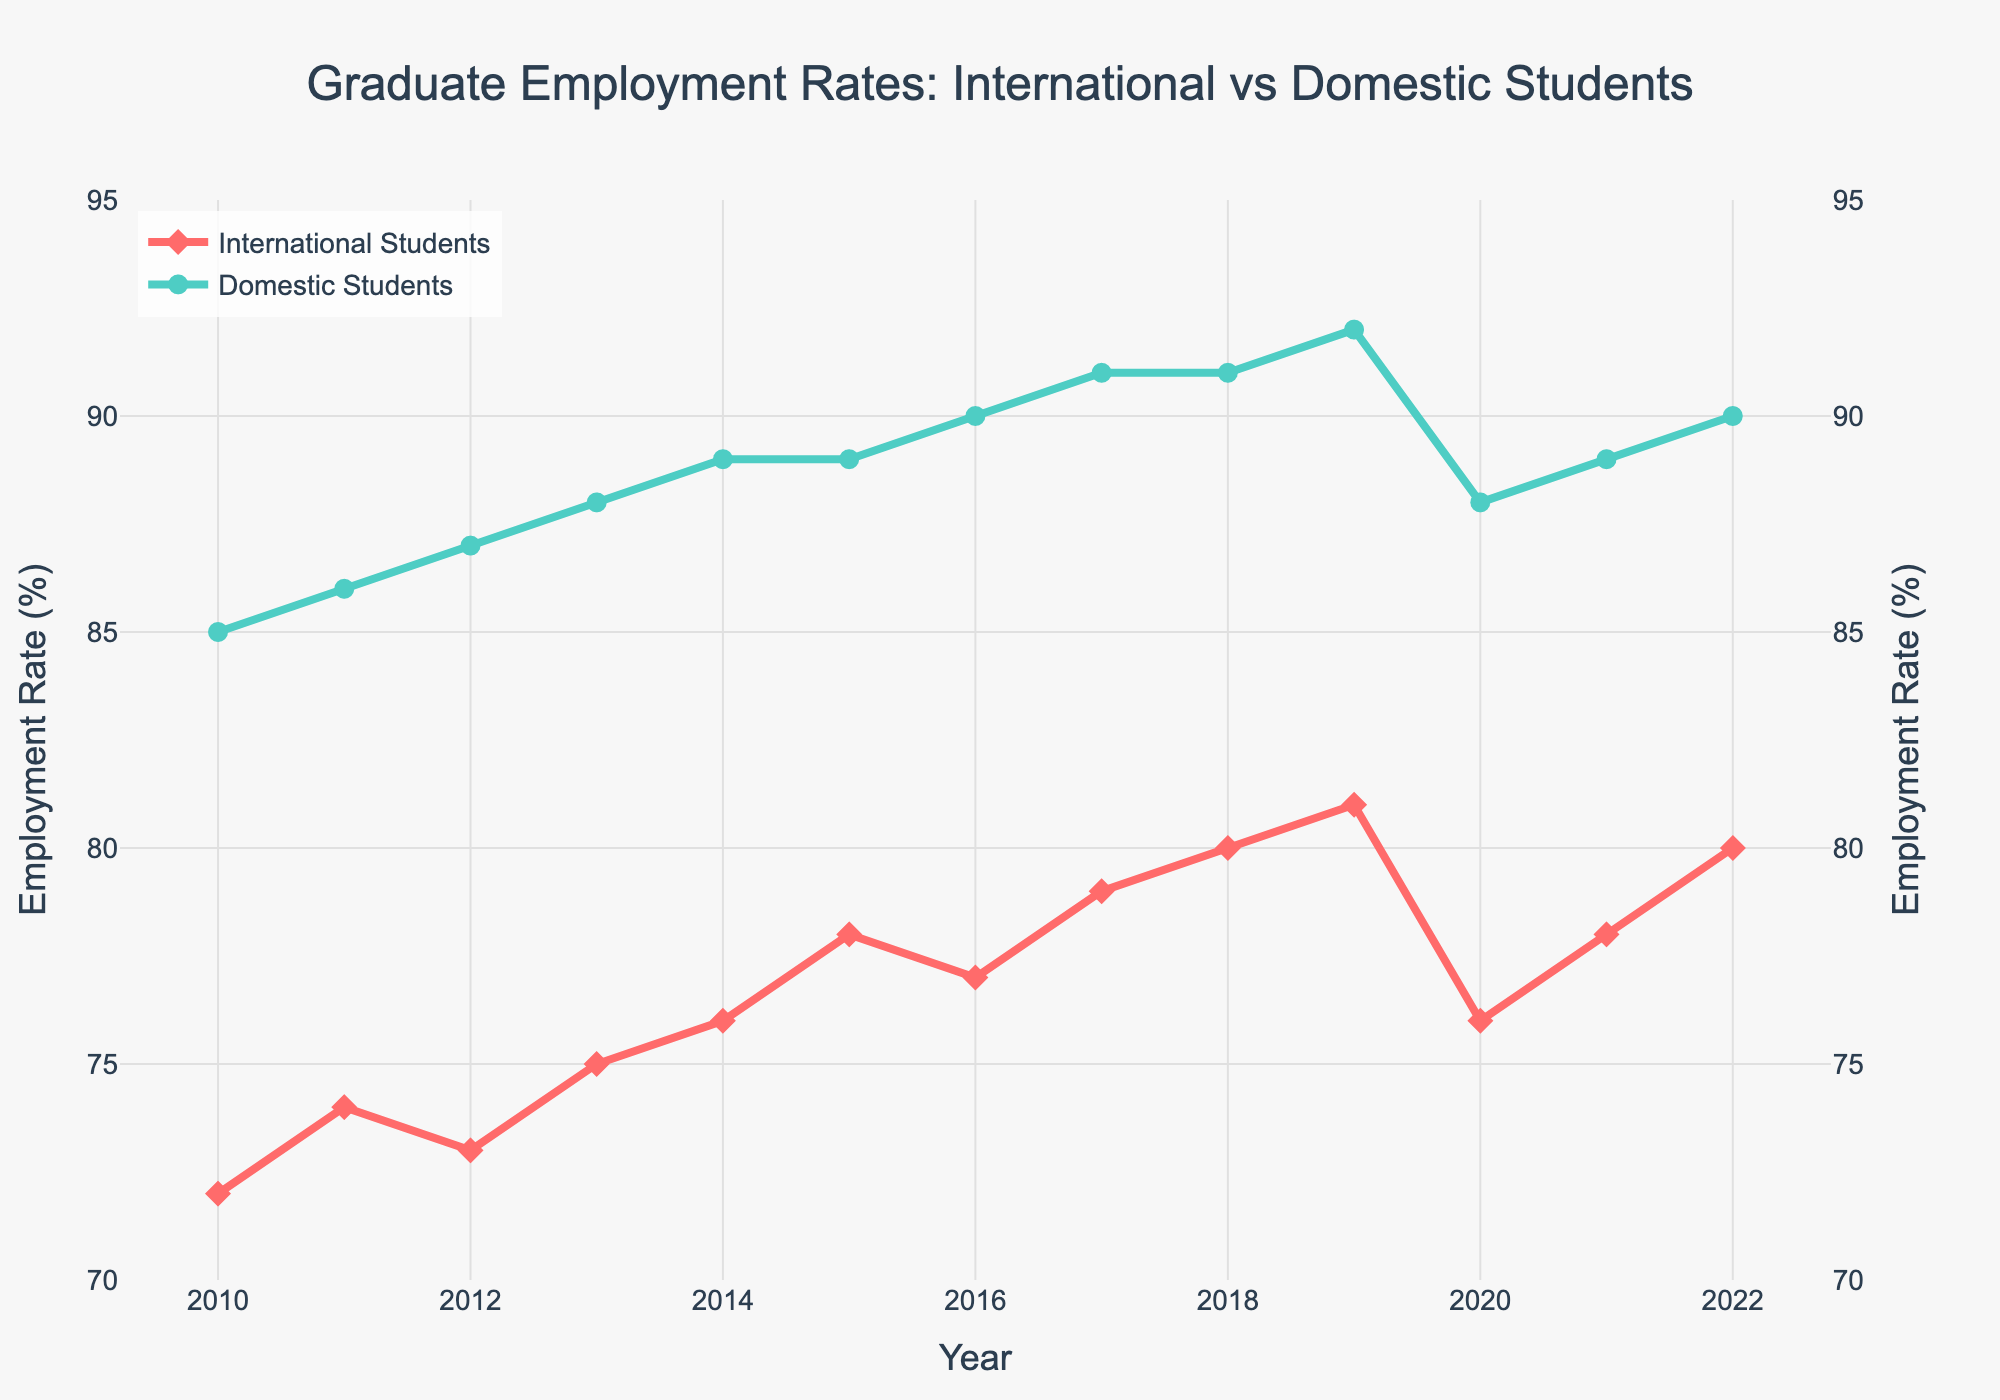What year did the employment rate for international students see the largest drop? The employment rate for international students dropped the most between 2019 and 2020. In 2019, the rate was 81%, and in 2020, it was 76%. This is a 5% decrease.
Answer: 2020 How does the employment rate of domestic students in 2015 compare to that of international students in the same year? In 2015, the employment rate for domestic students was 89%, while for international students, it was 78%. The rate for domestic students was 11% higher than that for international students.
Answer: 11% higher What is the average employment rate for international students from 2010 to 2020? To calculate the average, add up the employment rates for international students from 2010 to 2020 and divide by the number of years: (72+74+73+75+76+78+77+79+80+81+76)/11 = 76.27%.
Answer: 76.27% Which year marks the peak employment rate for domestic students, and what is that rate? The peak employment rate for domestic students occurred in 2019, with a rate of 92%.
Answer: 2019, 92% Did the employment rate for international students ever surpass the lowest employment rate for domestic students? The lowest employment rate for domestic students was 85% in 2010. The highest employment rate for international students was 81% in 2019. Thus, the employment rate for international students never surpassed the lowest for domestic students.
Answer: No Compare the overall trend in employment rates for international students with that for domestic students from 2010 to 2022. Both international and domestic students show an overall increasing trend in employment rates from 2010 to 2022. However, the rate of increase is generally higher for domestic students.
Answer: Increasing but higher for domestic What is the difference in employment rates between international and domestic students in 2022? In 2022, the employment rates for international and domestic students were 80% and 90%, respectively. The difference is 90% - 80% = 10%.
Answer: 10% What is the average rate of increase of employment for international students between 2010 and 2019? To calculate the average rate of increase, find the increase from 2010 to 2019 and divide by the number of years: (81 - 72)/9 = 1%.
Answer: 1% Identify any years where both international and domestic student employment rates decreased compared to the previous year. Both rates decreased from 2019 to 2020. For international students, the rate fell from 81% to 76%, and for domestic students, it fell from 92% to 88%.
Answer: 2019-2020 What's the difference between the highest employment rate of domestic students and the lowest rate of international students within this period? Domestic students had a highest employment rate of 92% in 2019, and international students had a lowest rate of 72% in 2010. The difference is 92% - 72% = 20%.
Answer: 20% 